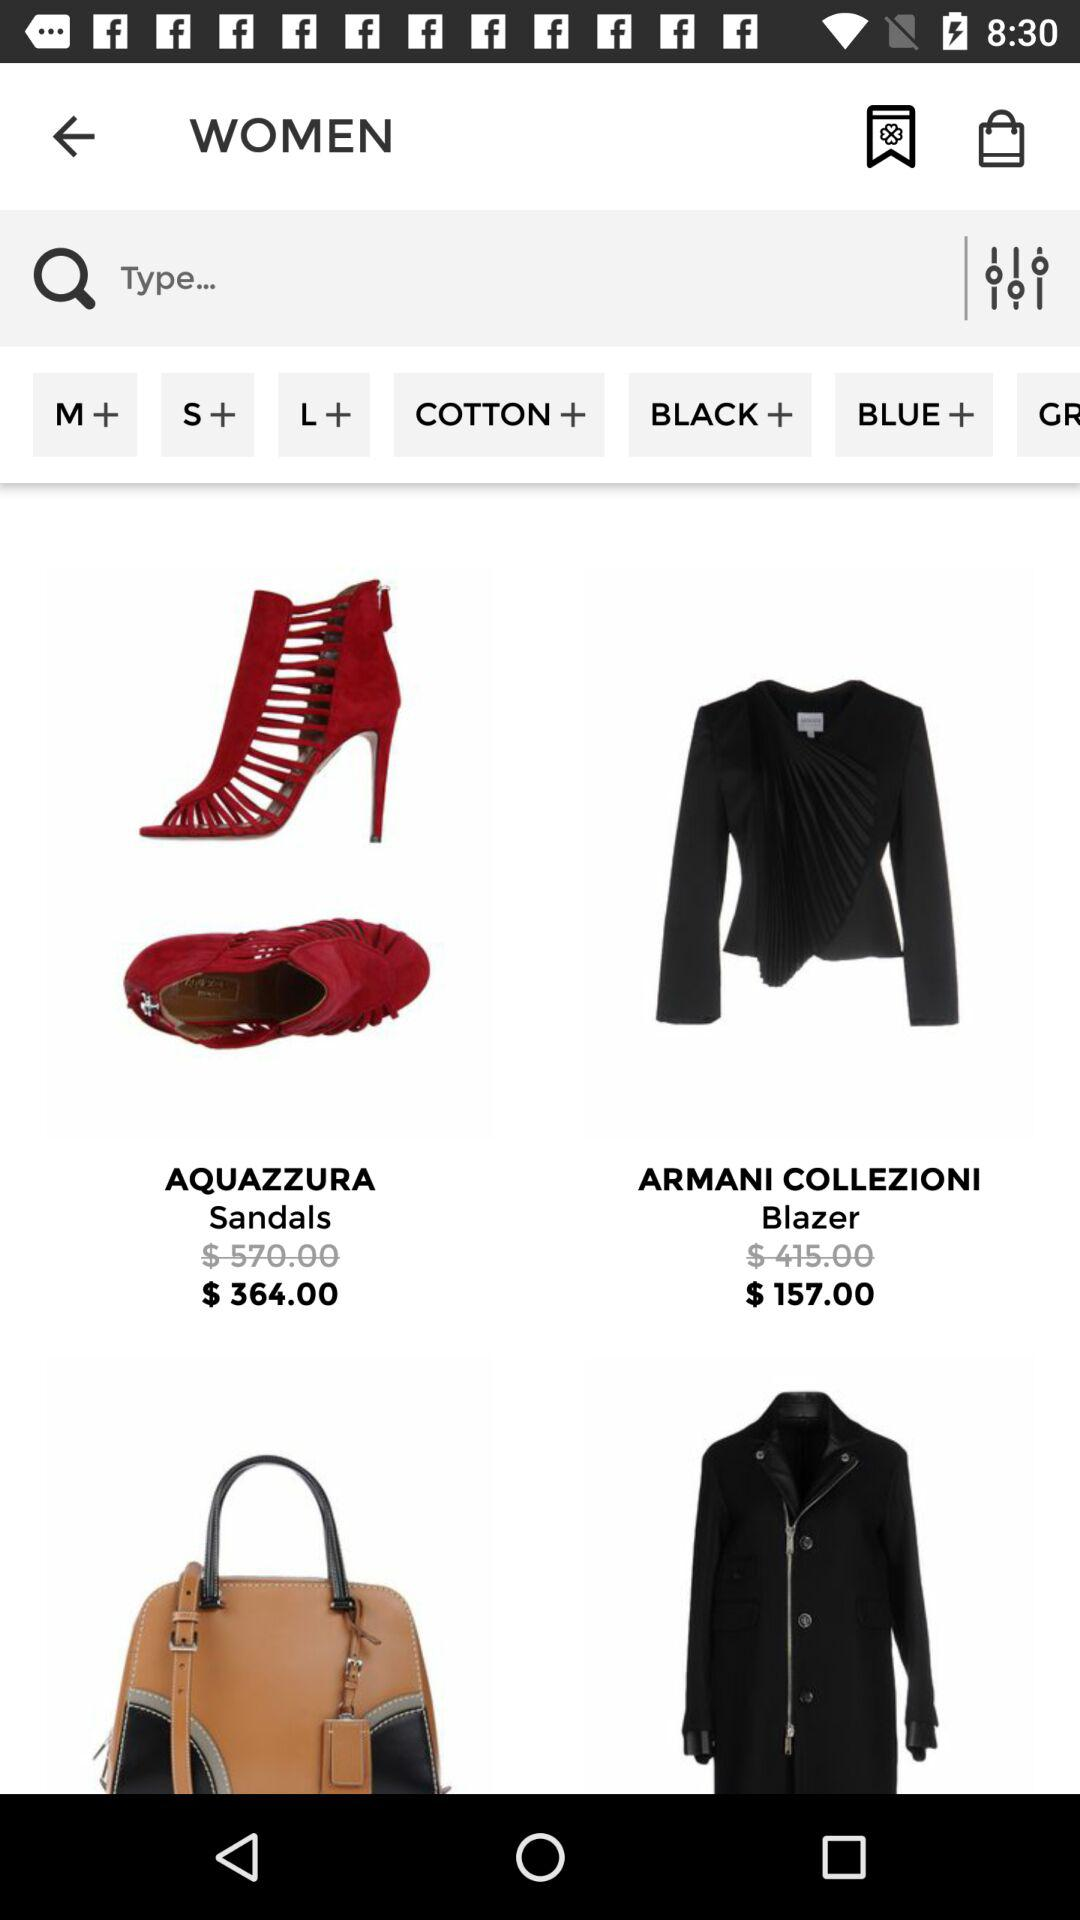What is the price of aquazzura sandals? The price is $364.00. 